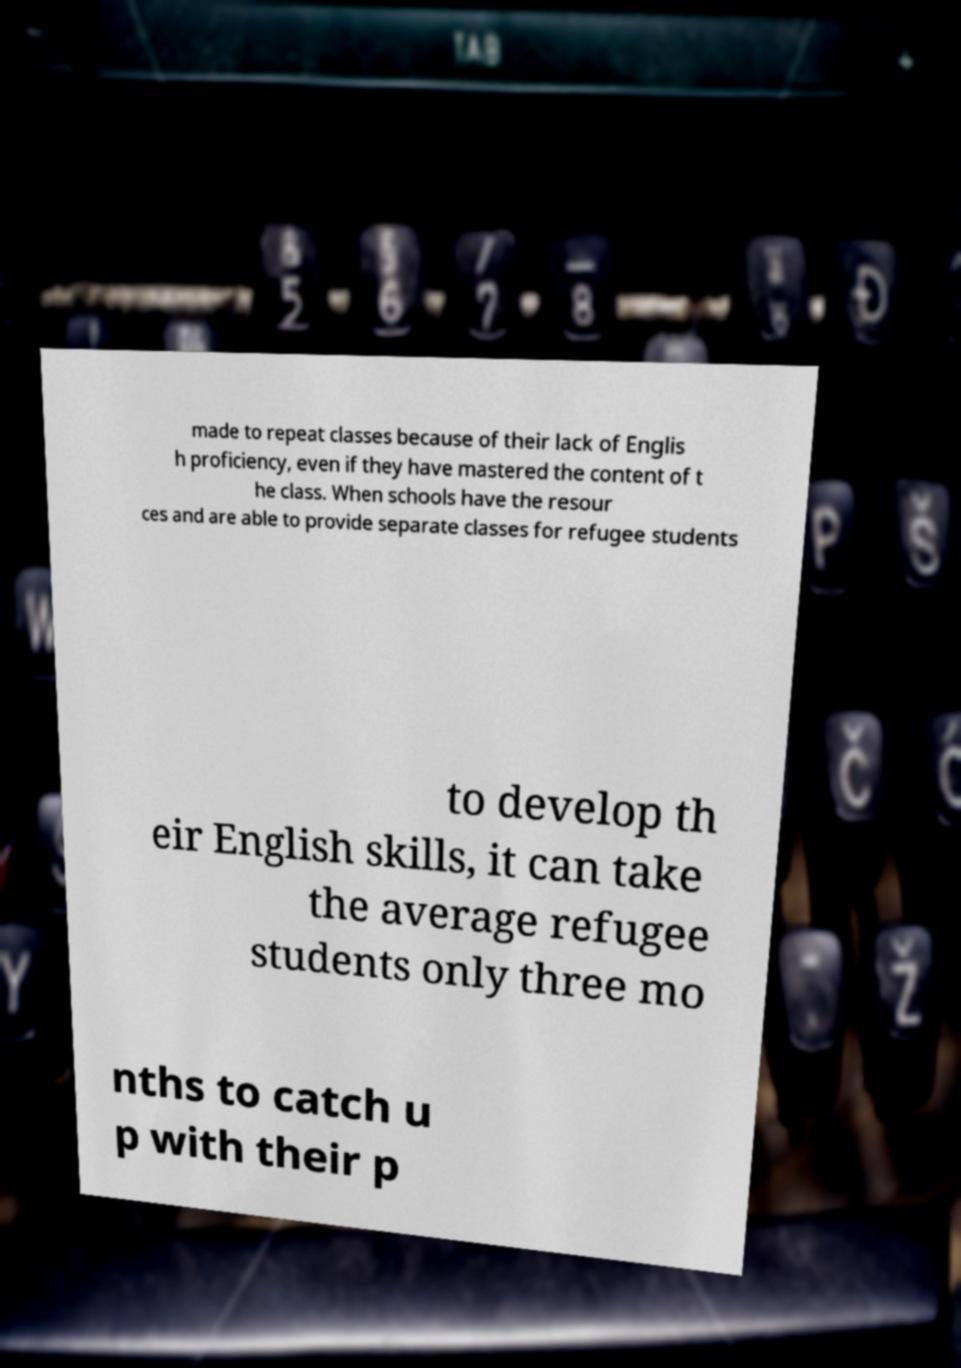Can you accurately transcribe the text from the provided image for me? made to repeat classes because of their lack of Englis h proficiency, even if they have mastered the content of t he class. When schools have the resour ces and are able to provide separate classes for refugee students to develop th eir English skills, it can take the average refugee students only three mo nths to catch u p with their p 